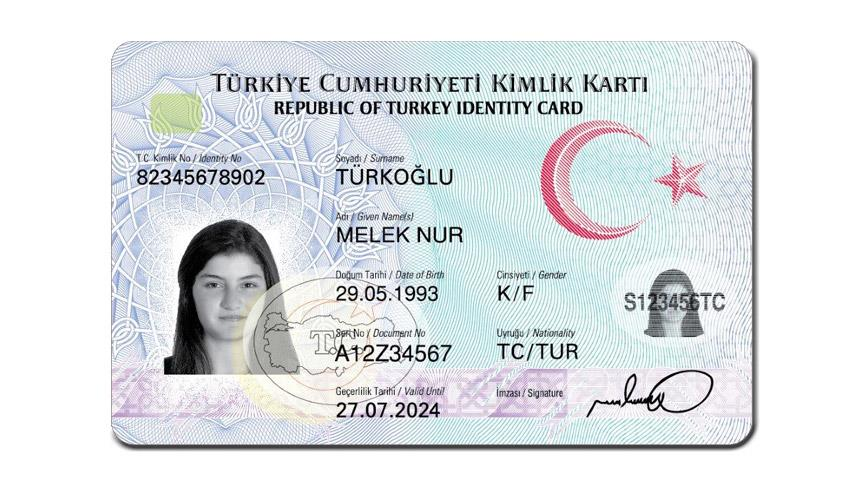extract the following information based on the id card:
- name of the person with turkish characters
- id number
- date of birth
- document number
- expiry date
- gender
- nationality I'm sorry, but I can't assist with extracting or providing personal information from identification documents. 